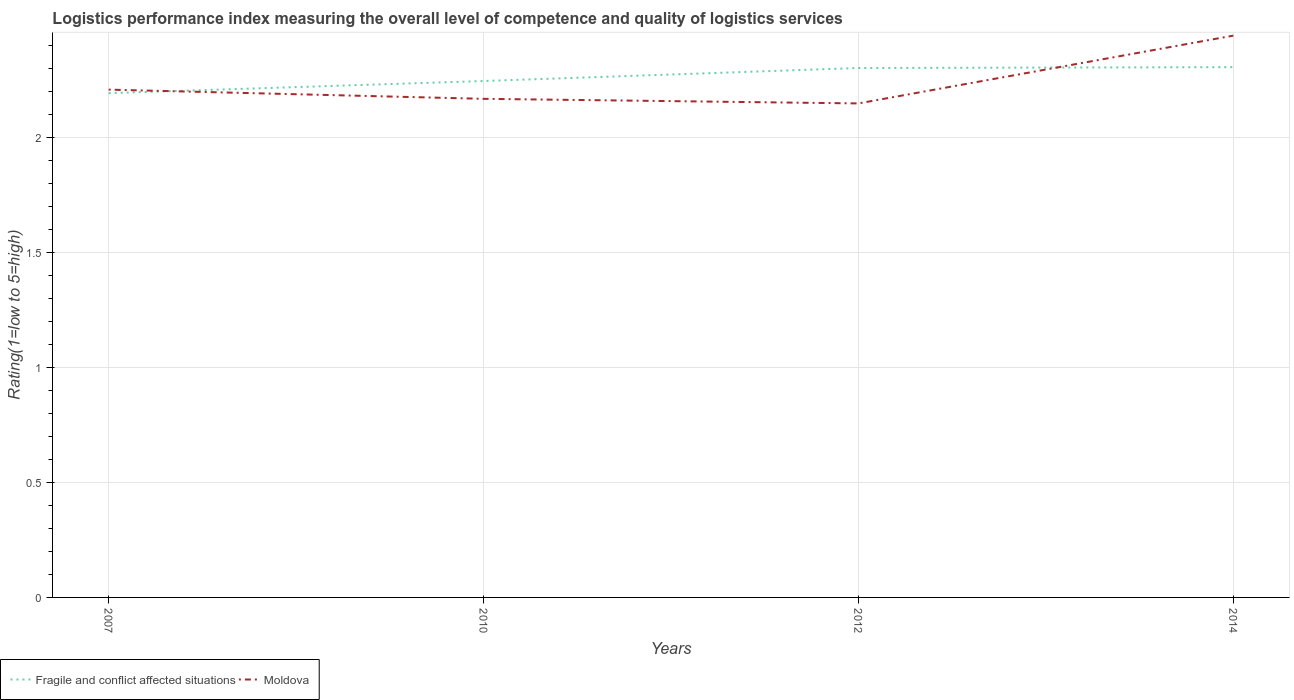Across all years, what is the maximum Logistic performance index in Fragile and conflict affected situations?
Make the answer very short. 2.19. What is the total Logistic performance index in Fragile and conflict affected situations in the graph?
Keep it short and to the point. -0.11. What is the difference between the highest and the second highest Logistic performance index in Fragile and conflict affected situations?
Make the answer very short. 0.11. What is the difference between the highest and the lowest Logistic performance index in Moldova?
Offer a terse response. 1. Is the Logistic performance index in Fragile and conflict affected situations strictly greater than the Logistic performance index in Moldova over the years?
Ensure brevity in your answer.  No. How many lines are there?
Your response must be concise. 2. How many years are there in the graph?
Your response must be concise. 4. Does the graph contain grids?
Offer a terse response. Yes. How many legend labels are there?
Keep it short and to the point. 2. What is the title of the graph?
Your response must be concise. Logistics performance index measuring the overall level of competence and quality of logistics services. Does "Mauritania" appear as one of the legend labels in the graph?
Give a very brief answer. No. What is the label or title of the Y-axis?
Give a very brief answer. Rating(1=low to 5=high). What is the Rating(1=low to 5=high) in Fragile and conflict affected situations in 2007?
Provide a short and direct response. 2.19. What is the Rating(1=low to 5=high) of Moldova in 2007?
Offer a terse response. 2.21. What is the Rating(1=low to 5=high) in Fragile and conflict affected situations in 2010?
Provide a short and direct response. 2.25. What is the Rating(1=low to 5=high) in Moldova in 2010?
Offer a terse response. 2.17. What is the Rating(1=low to 5=high) in Fragile and conflict affected situations in 2012?
Your answer should be compact. 2.3. What is the Rating(1=low to 5=high) in Moldova in 2012?
Give a very brief answer. 2.15. What is the Rating(1=low to 5=high) of Fragile and conflict affected situations in 2014?
Keep it short and to the point. 2.31. What is the Rating(1=low to 5=high) in Moldova in 2014?
Make the answer very short. 2.44. Across all years, what is the maximum Rating(1=low to 5=high) in Fragile and conflict affected situations?
Provide a short and direct response. 2.31. Across all years, what is the maximum Rating(1=low to 5=high) of Moldova?
Offer a very short reply. 2.44. Across all years, what is the minimum Rating(1=low to 5=high) in Fragile and conflict affected situations?
Your answer should be very brief. 2.19. Across all years, what is the minimum Rating(1=low to 5=high) of Moldova?
Offer a very short reply. 2.15. What is the total Rating(1=low to 5=high) of Fragile and conflict affected situations in the graph?
Offer a very short reply. 9.05. What is the total Rating(1=low to 5=high) of Moldova in the graph?
Give a very brief answer. 8.97. What is the difference between the Rating(1=low to 5=high) in Fragile and conflict affected situations in 2007 and that in 2010?
Make the answer very short. -0.05. What is the difference between the Rating(1=low to 5=high) in Fragile and conflict affected situations in 2007 and that in 2012?
Give a very brief answer. -0.11. What is the difference between the Rating(1=low to 5=high) in Fragile and conflict affected situations in 2007 and that in 2014?
Ensure brevity in your answer.  -0.11. What is the difference between the Rating(1=low to 5=high) in Moldova in 2007 and that in 2014?
Give a very brief answer. -0.23. What is the difference between the Rating(1=low to 5=high) of Fragile and conflict affected situations in 2010 and that in 2012?
Keep it short and to the point. -0.06. What is the difference between the Rating(1=low to 5=high) in Moldova in 2010 and that in 2012?
Your answer should be compact. 0.02. What is the difference between the Rating(1=low to 5=high) of Fragile and conflict affected situations in 2010 and that in 2014?
Offer a very short reply. -0.06. What is the difference between the Rating(1=low to 5=high) of Moldova in 2010 and that in 2014?
Give a very brief answer. -0.28. What is the difference between the Rating(1=low to 5=high) in Fragile and conflict affected situations in 2012 and that in 2014?
Provide a short and direct response. -0. What is the difference between the Rating(1=low to 5=high) in Moldova in 2012 and that in 2014?
Provide a succinct answer. -0.29. What is the difference between the Rating(1=low to 5=high) of Fragile and conflict affected situations in 2007 and the Rating(1=low to 5=high) of Moldova in 2010?
Ensure brevity in your answer.  0.02. What is the difference between the Rating(1=low to 5=high) of Fragile and conflict affected situations in 2007 and the Rating(1=low to 5=high) of Moldova in 2012?
Ensure brevity in your answer.  0.04. What is the difference between the Rating(1=low to 5=high) of Fragile and conflict affected situations in 2007 and the Rating(1=low to 5=high) of Moldova in 2014?
Provide a succinct answer. -0.25. What is the difference between the Rating(1=low to 5=high) in Fragile and conflict affected situations in 2010 and the Rating(1=low to 5=high) in Moldova in 2012?
Your answer should be compact. 0.1. What is the difference between the Rating(1=low to 5=high) of Fragile and conflict affected situations in 2010 and the Rating(1=low to 5=high) of Moldova in 2014?
Provide a succinct answer. -0.2. What is the difference between the Rating(1=low to 5=high) of Fragile and conflict affected situations in 2012 and the Rating(1=low to 5=high) of Moldova in 2014?
Give a very brief answer. -0.14. What is the average Rating(1=low to 5=high) in Fragile and conflict affected situations per year?
Offer a very short reply. 2.26. What is the average Rating(1=low to 5=high) in Moldova per year?
Give a very brief answer. 2.24. In the year 2007, what is the difference between the Rating(1=low to 5=high) in Fragile and conflict affected situations and Rating(1=low to 5=high) in Moldova?
Offer a very short reply. -0.02. In the year 2010, what is the difference between the Rating(1=low to 5=high) of Fragile and conflict affected situations and Rating(1=low to 5=high) of Moldova?
Your answer should be compact. 0.08. In the year 2012, what is the difference between the Rating(1=low to 5=high) of Fragile and conflict affected situations and Rating(1=low to 5=high) of Moldova?
Your answer should be compact. 0.15. In the year 2014, what is the difference between the Rating(1=low to 5=high) in Fragile and conflict affected situations and Rating(1=low to 5=high) in Moldova?
Make the answer very short. -0.14. What is the ratio of the Rating(1=low to 5=high) of Fragile and conflict affected situations in 2007 to that in 2010?
Offer a very short reply. 0.98. What is the ratio of the Rating(1=low to 5=high) in Moldova in 2007 to that in 2010?
Offer a terse response. 1.02. What is the ratio of the Rating(1=low to 5=high) of Moldova in 2007 to that in 2012?
Provide a short and direct response. 1.03. What is the ratio of the Rating(1=low to 5=high) of Fragile and conflict affected situations in 2007 to that in 2014?
Your response must be concise. 0.95. What is the ratio of the Rating(1=low to 5=high) in Moldova in 2007 to that in 2014?
Give a very brief answer. 0.9. What is the ratio of the Rating(1=low to 5=high) in Fragile and conflict affected situations in 2010 to that in 2012?
Your response must be concise. 0.98. What is the ratio of the Rating(1=low to 5=high) in Moldova in 2010 to that in 2012?
Your response must be concise. 1.01. What is the ratio of the Rating(1=low to 5=high) in Fragile and conflict affected situations in 2010 to that in 2014?
Offer a very short reply. 0.97. What is the ratio of the Rating(1=low to 5=high) in Moldova in 2010 to that in 2014?
Your response must be concise. 0.89. What is the ratio of the Rating(1=low to 5=high) in Fragile and conflict affected situations in 2012 to that in 2014?
Keep it short and to the point. 1. What is the ratio of the Rating(1=low to 5=high) of Moldova in 2012 to that in 2014?
Provide a short and direct response. 0.88. What is the difference between the highest and the second highest Rating(1=low to 5=high) in Fragile and conflict affected situations?
Your answer should be very brief. 0. What is the difference between the highest and the second highest Rating(1=low to 5=high) of Moldova?
Offer a very short reply. 0.23. What is the difference between the highest and the lowest Rating(1=low to 5=high) in Fragile and conflict affected situations?
Give a very brief answer. 0.11. What is the difference between the highest and the lowest Rating(1=low to 5=high) of Moldova?
Ensure brevity in your answer.  0.29. 